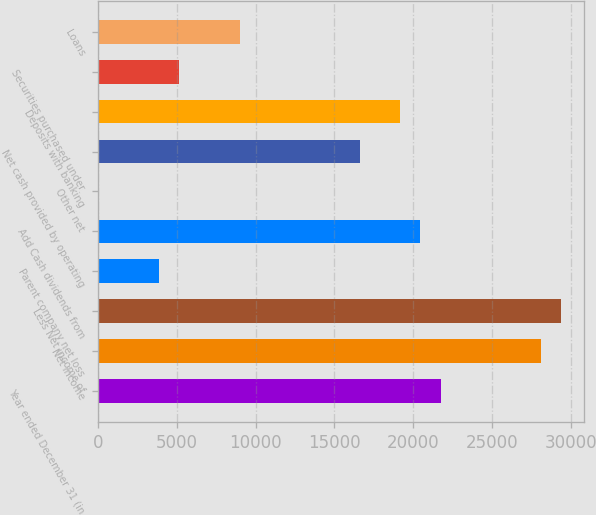Convert chart to OTSL. <chart><loc_0><loc_0><loc_500><loc_500><bar_chart><fcel>Year ended December 31 (in<fcel>Net income<fcel>Less Net income of<fcel>Parent company net loss<fcel>Add Cash dividends from<fcel>Other net<fcel>Net cash provided by operating<fcel>Deposits with banking<fcel>Securities purchased under<fcel>Loans<nl><fcel>21730.5<fcel>28098<fcel>29371.5<fcel>3901.5<fcel>20457<fcel>81<fcel>16636.5<fcel>19183.5<fcel>5175<fcel>8995.5<nl></chart> 